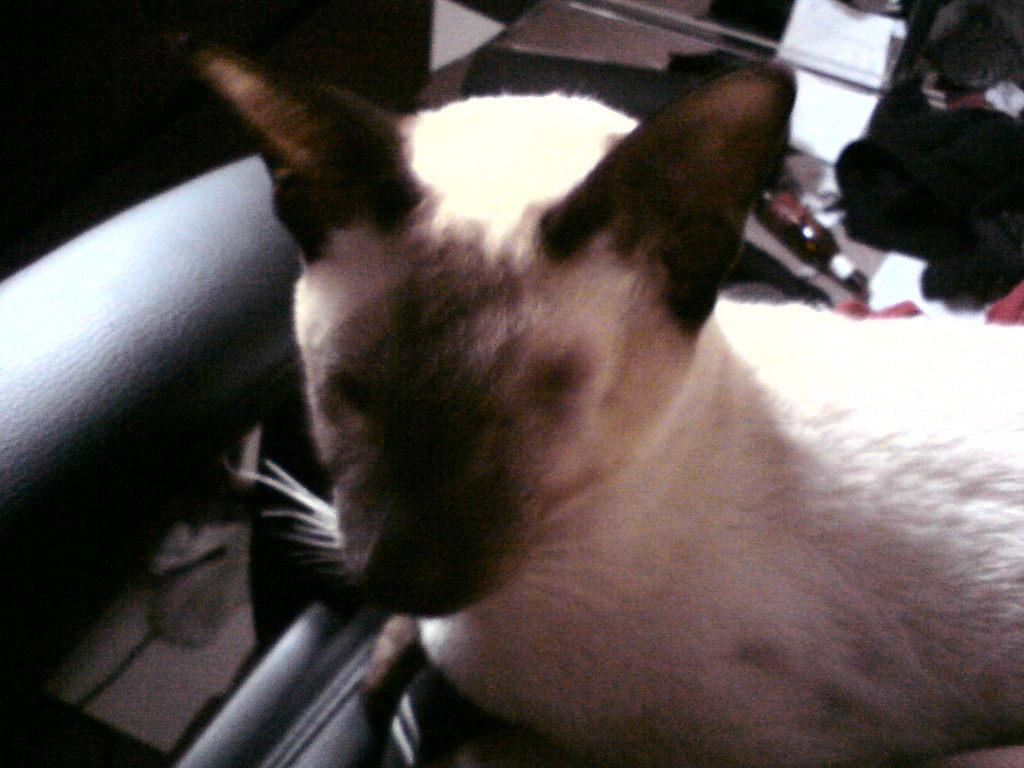What is the main subject on the chair in the image? There is an animal on a chair in the image. What else can be seen in the image besides the animal on the chair? There is a bottle visible in the image. What might be found on the floor in the image? There are clothes on the floor in the image. How many bridges can be seen in the image? There are no bridges present in the image. What type of peace symbol is visible in the image? There is no peace symbol present in the image. 